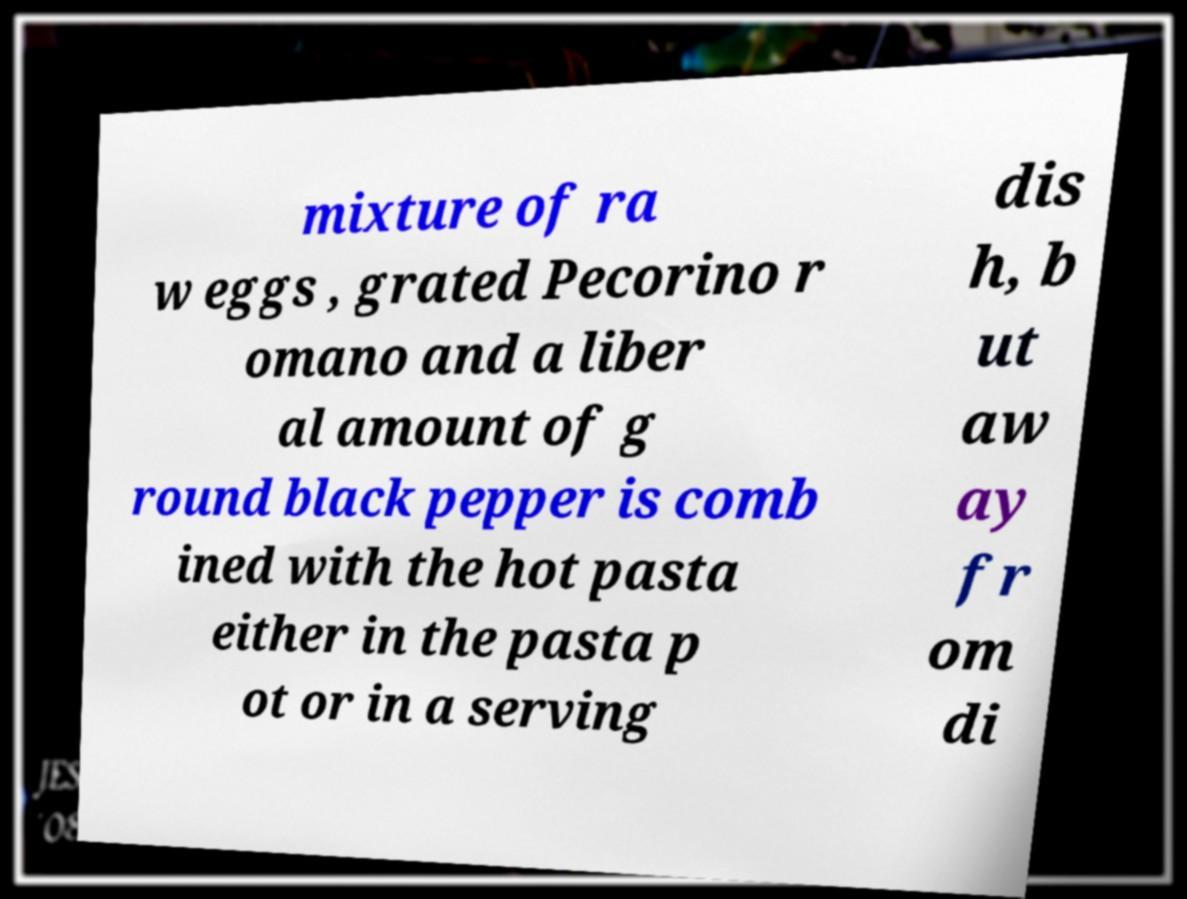Please read and relay the text visible in this image. What does it say? mixture of ra w eggs , grated Pecorino r omano and a liber al amount of g round black pepper is comb ined with the hot pasta either in the pasta p ot or in a serving dis h, b ut aw ay fr om di 